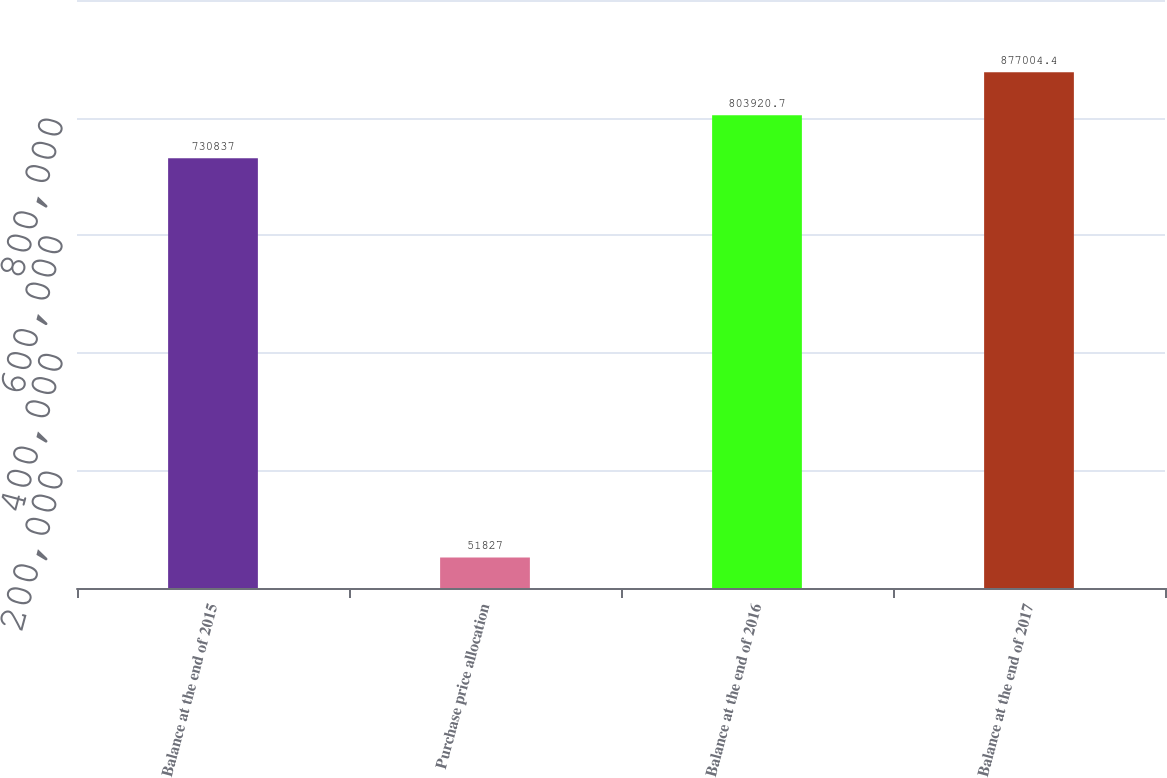Convert chart. <chart><loc_0><loc_0><loc_500><loc_500><bar_chart><fcel>Balance at the end of 2015<fcel>Purchase price allocation<fcel>Balance at the end of 2016<fcel>Balance at the end of 2017<nl><fcel>730837<fcel>51827<fcel>803921<fcel>877004<nl></chart> 